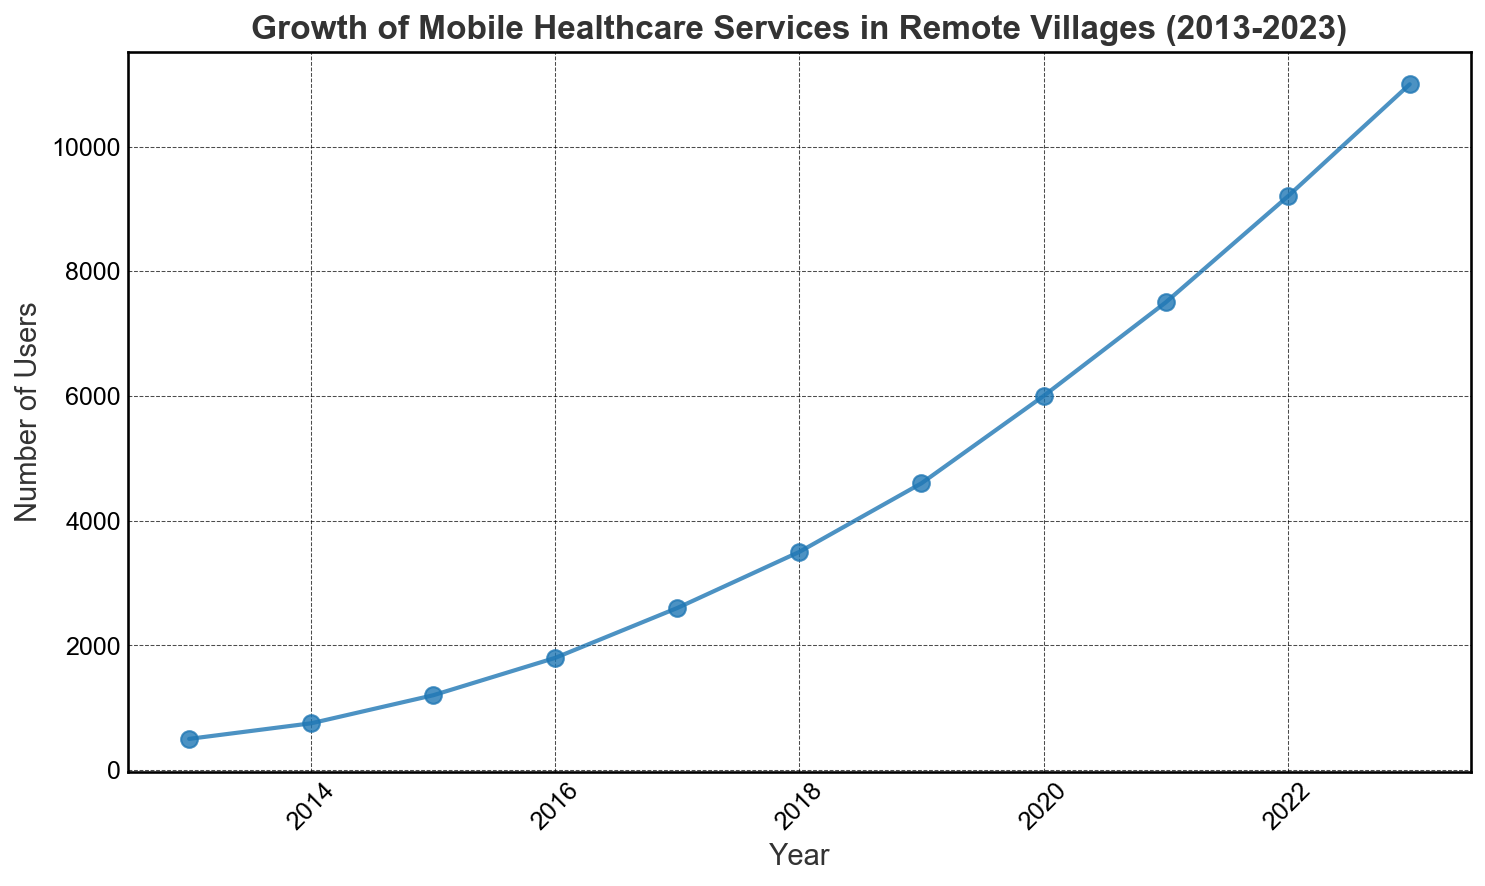what is the total number of users in 2023 compared to 2013? In 2023, there are 11,000 users, and in 2013, there were 500 users. The difference in the number of users between these years is 11,000 - 500. Hence, the total number of users increased by 10,500.
Answer: 10,500 which year had the highest number of users' growth compared to the previous year? To find the year with the highest growth, calculate the differences in users between consecutive years: 
750-500 = 250,
1200-750 = 450,
1800-1200 = 600,
2600-1800 = 800,
3500-2600 = 900,
4600-3500 = 1100,
6000-4600 = 1400,
7500-6000 = 1500,
9200-7500 = 1700,
11000-9200 = 1800.
The highest growth is from 2022 to 2023, which is 1,800 users.
Answer: 2022-2023 what is the average annual growth in the number of users over the 10-year period? To find the average annual growth, calculate the total growth over the entire period and divide by the number of years. Total growth is 11,000 (2023) - 500 (2013) = 10,500. The period is 10 years. So, the average annual growth is 10,500 / 10.
Answer: 1,050 which was the first year the number of users crossed 5,000? Looking at the data for each year, 2020 is the first year in which the number of users, 6000, exceeds 5,000.
Answer: 2020 how does the user growth from 2013 to 2018 compare to the user growth from 2018 to 2023? Calculate growth from 2013 to 2018: 3500 (2018) - 500 (2013) = 3000. Next, calculate the growth from 2018 to 2023: 11000 (2023) - 3500 (2018) = 7500. Comparing these, the growth from 2018 to 2023 is more significant.
Answer: Growth from 2018-2023 is higher during which year was the smallest increase in the number of users observed? Calculate the differences between consecutive years: 
750-500 = 250,
1200-750 = 450,
1800-1200 = 600,
2600-1800 = 800,
3500-2600 = 900,
4600-3500 = 1100,
6000-4600 = 1400,
7500-6000 = 1500,
9200-7500 = 1700,
11000-9200 = 1800.
The smallest increase observed is 250 users, which occurred from 2013 to 2014.
Answer: 2013-2014 what is the median number of users over the 11 years? To find the median, list the numbers in order and find the middle number. The sorted list is: 500, 750, 1200, 1800, 2600, 3500, 4600, 6000, 7500, 9200, 11000. The median is the middle number, which is 3500.
Answer: 3500 